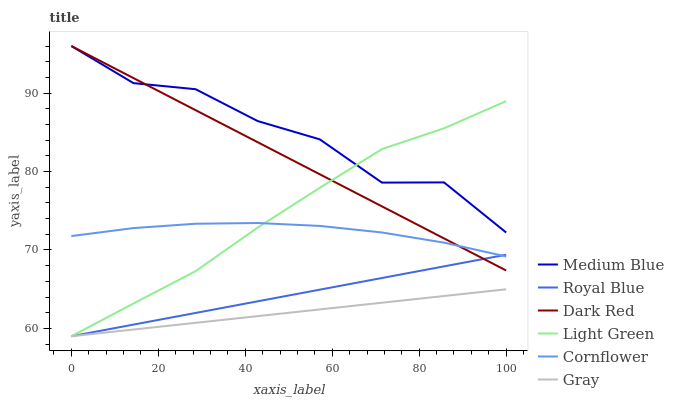Does Gray have the minimum area under the curve?
Answer yes or no. Yes. Does Medium Blue have the maximum area under the curve?
Answer yes or no. Yes. Does Cornflower have the minimum area under the curve?
Answer yes or no. No. Does Cornflower have the maximum area under the curve?
Answer yes or no. No. Is Dark Red the smoothest?
Answer yes or no. Yes. Is Medium Blue the roughest?
Answer yes or no. Yes. Is Cornflower the smoothest?
Answer yes or no. No. Is Cornflower the roughest?
Answer yes or no. No. Does Gray have the lowest value?
Answer yes or no. Yes. Does Cornflower have the lowest value?
Answer yes or no. No. Does Medium Blue have the highest value?
Answer yes or no. Yes. Does Cornflower have the highest value?
Answer yes or no. No. Is Gray less than Medium Blue?
Answer yes or no. Yes. Is Medium Blue greater than Cornflower?
Answer yes or no. Yes. Does Royal Blue intersect Light Green?
Answer yes or no. Yes. Is Royal Blue less than Light Green?
Answer yes or no. No. Is Royal Blue greater than Light Green?
Answer yes or no. No. Does Gray intersect Medium Blue?
Answer yes or no. No. 